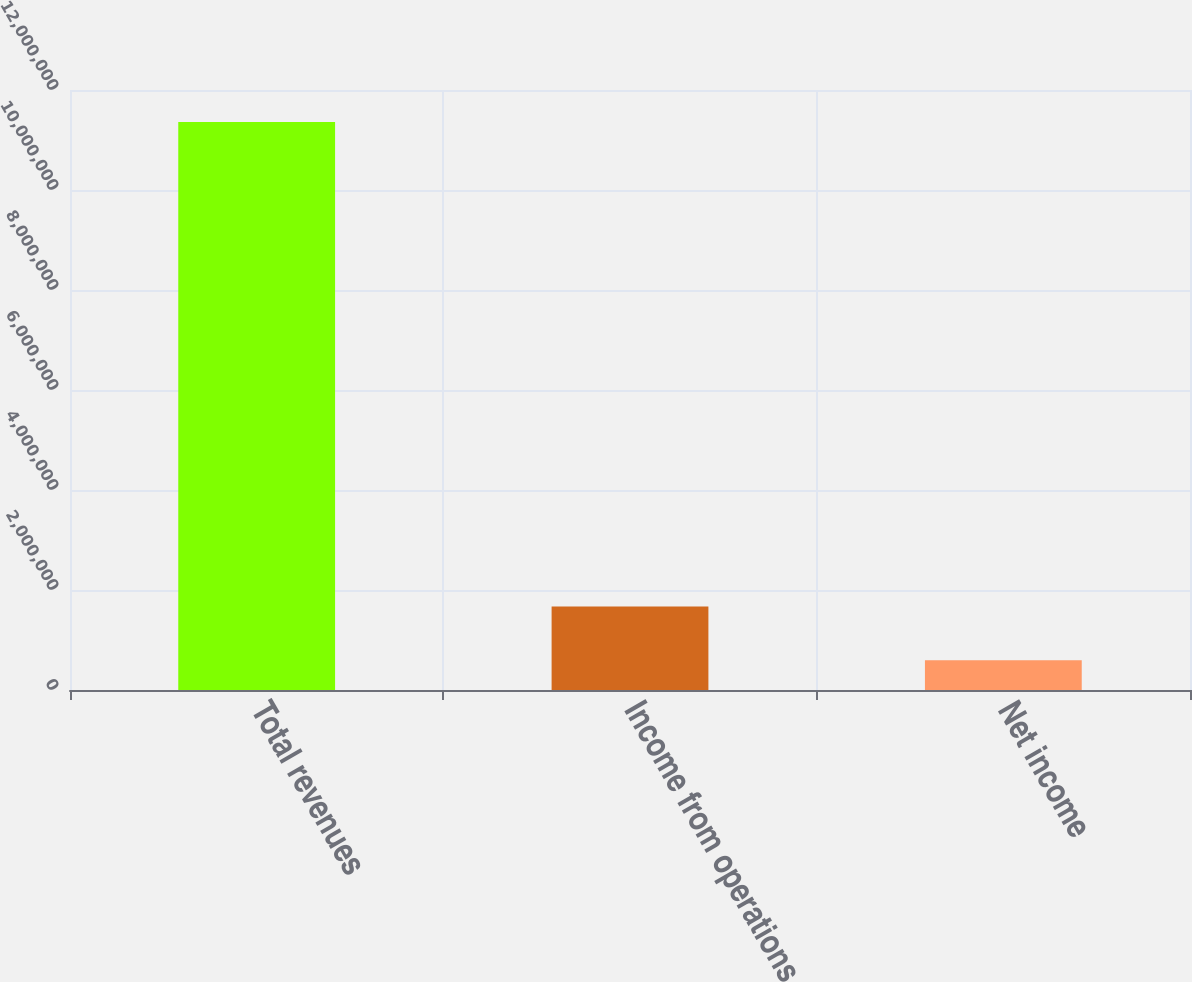Convert chart. <chart><loc_0><loc_0><loc_500><loc_500><bar_chart><fcel>Total revenues<fcel>Income from operations<fcel>Net income<nl><fcel>1.13591e+07<fcel>1.67033e+06<fcel>593804<nl></chart> 